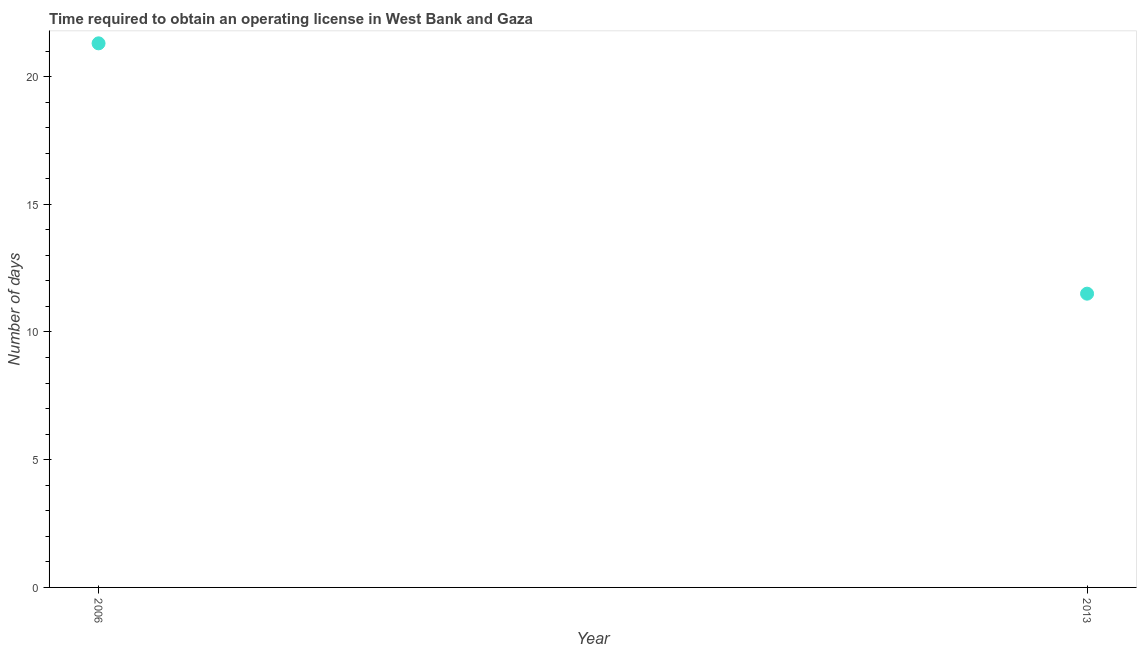What is the number of days to obtain operating license in 2006?
Your answer should be very brief. 21.3. Across all years, what is the maximum number of days to obtain operating license?
Give a very brief answer. 21.3. Across all years, what is the minimum number of days to obtain operating license?
Make the answer very short. 11.5. In which year was the number of days to obtain operating license maximum?
Keep it short and to the point. 2006. In which year was the number of days to obtain operating license minimum?
Offer a terse response. 2013. What is the sum of the number of days to obtain operating license?
Provide a succinct answer. 32.8. What is the difference between the number of days to obtain operating license in 2006 and 2013?
Offer a terse response. 9.8. What is the median number of days to obtain operating license?
Offer a terse response. 16.4. In how many years, is the number of days to obtain operating license greater than 3 days?
Keep it short and to the point. 2. What is the ratio of the number of days to obtain operating license in 2006 to that in 2013?
Give a very brief answer. 1.85. In how many years, is the number of days to obtain operating license greater than the average number of days to obtain operating license taken over all years?
Offer a very short reply. 1. Does the number of days to obtain operating license monotonically increase over the years?
Keep it short and to the point. No. How many years are there in the graph?
Offer a very short reply. 2. Are the values on the major ticks of Y-axis written in scientific E-notation?
Your response must be concise. No. Does the graph contain any zero values?
Ensure brevity in your answer.  No. Does the graph contain grids?
Provide a succinct answer. No. What is the title of the graph?
Your response must be concise. Time required to obtain an operating license in West Bank and Gaza. What is the label or title of the Y-axis?
Give a very brief answer. Number of days. What is the Number of days in 2006?
Offer a very short reply. 21.3. What is the difference between the Number of days in 2006 and 2013?
Your answer should be very brief. 9.8. What is the ratio of the Number of days in 2006 to that in 2013?
Make the answer very short. 1.85. 